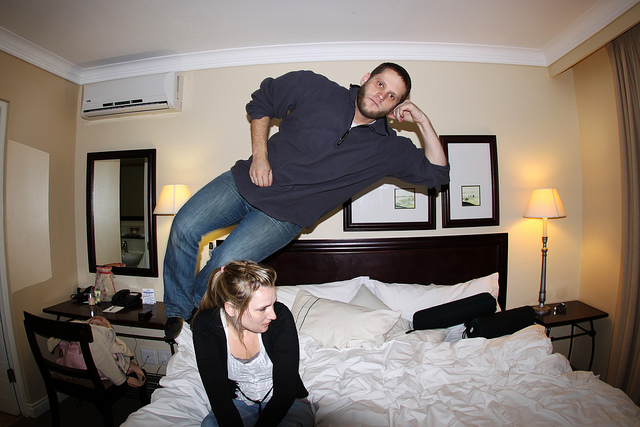What time of day does it seem to be in this photo? It's not possible to determine the exact time of day from the photo alone, as the curtains are drawn, and the room is illuminated by artificial lighting. The lighting does, however, suggest an evening or nighttime setting, when the room's lamps would typically be used. 